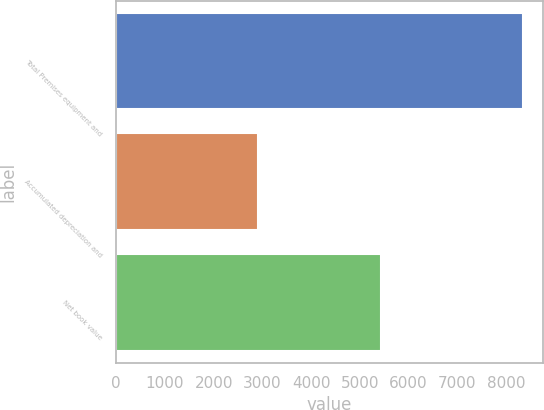<chart> <loc_0><loc_0><loc_500><loc_500><bar_chart><fcel>Total Premises equipment and<fcel>Accumulated depreciation and<fcel>Net book value<nl><fcel>8337<fcel>2909<fcel>5428<nl></chart> 